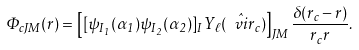Convert formula to latex. <formula><loc_0><loc_0><loc_500><loc_500>\Phi _ { c J M } ( r ) = \left [ [ \psi _ { I _ { 1 } } ( \alpha _ { 1 } ) \psi _ { I _ { 2 } } ( \alpha _ { 2 } ) ] _ { I } Y _ { \ell } ( \hat { \ v i r } _ { c } ) \right ] _ { J M } \frac { \delta ( r _ { c } - r ) } { r _ { c } r } .</formula> 